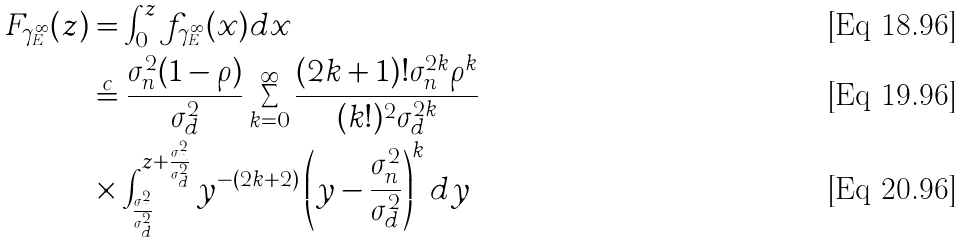<formula> <loc_0><loc_0><loc_500><loc_500>F _ { \gamma _ { E } ^ { \infty } } ( z ) & = \int _ { 0 } ^ { z } f _ { \gamma _ { E } ^ { \infty } } ( x ) d x \\ & \overset { c } { = } \frac { \sigma _ { n } ^ { 2 } ( 1 - \rho ) } { \sigma _ { d } ^ { 2 } } \sum _ { k = 0 } ^ { \infty } \frac { ( 2 k + 1 ) ! \sigma _ { n } ^ { 2 k } \rho ^ { k } } { ( k ! ) ^ { 2 } \sigma _ { d } ^ { 2 k } } \\ & \times \int _ { \frac { \sigma _ { n } ^ { 2 } } { \sigma _ { d } ^ { 2 } } } ^ { z + \frac { \sigma _ { n } ^ { 2 } } { \sigma _ { d } ^ { 2 } } } y ^ { - ( 2 k + 2 ) } \left ( y - \frac { \sigma _ { n } ^ { 2 } } { \sigma _ { d } ^ { 2 } } \right ) ^ { k } d y</formula> 